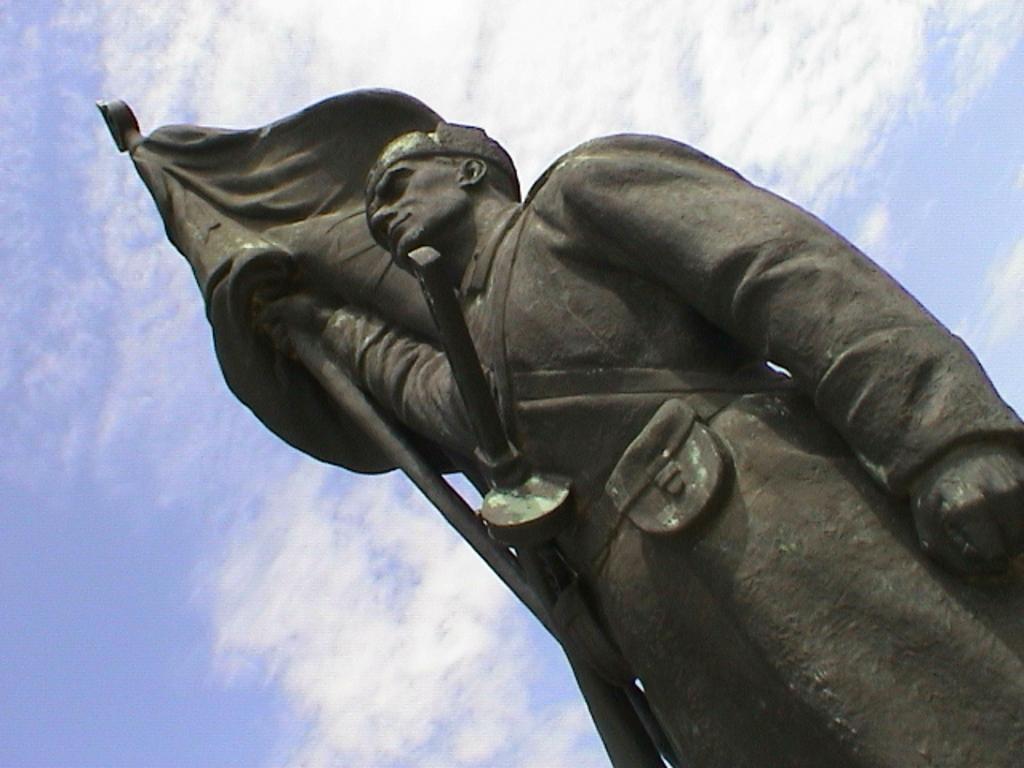Can you describe this image briefly? In this picture I can see there is a statue of a man and he is wearing a black color coat and he is holding a flag pole and there is a flag and the sky is clear. 